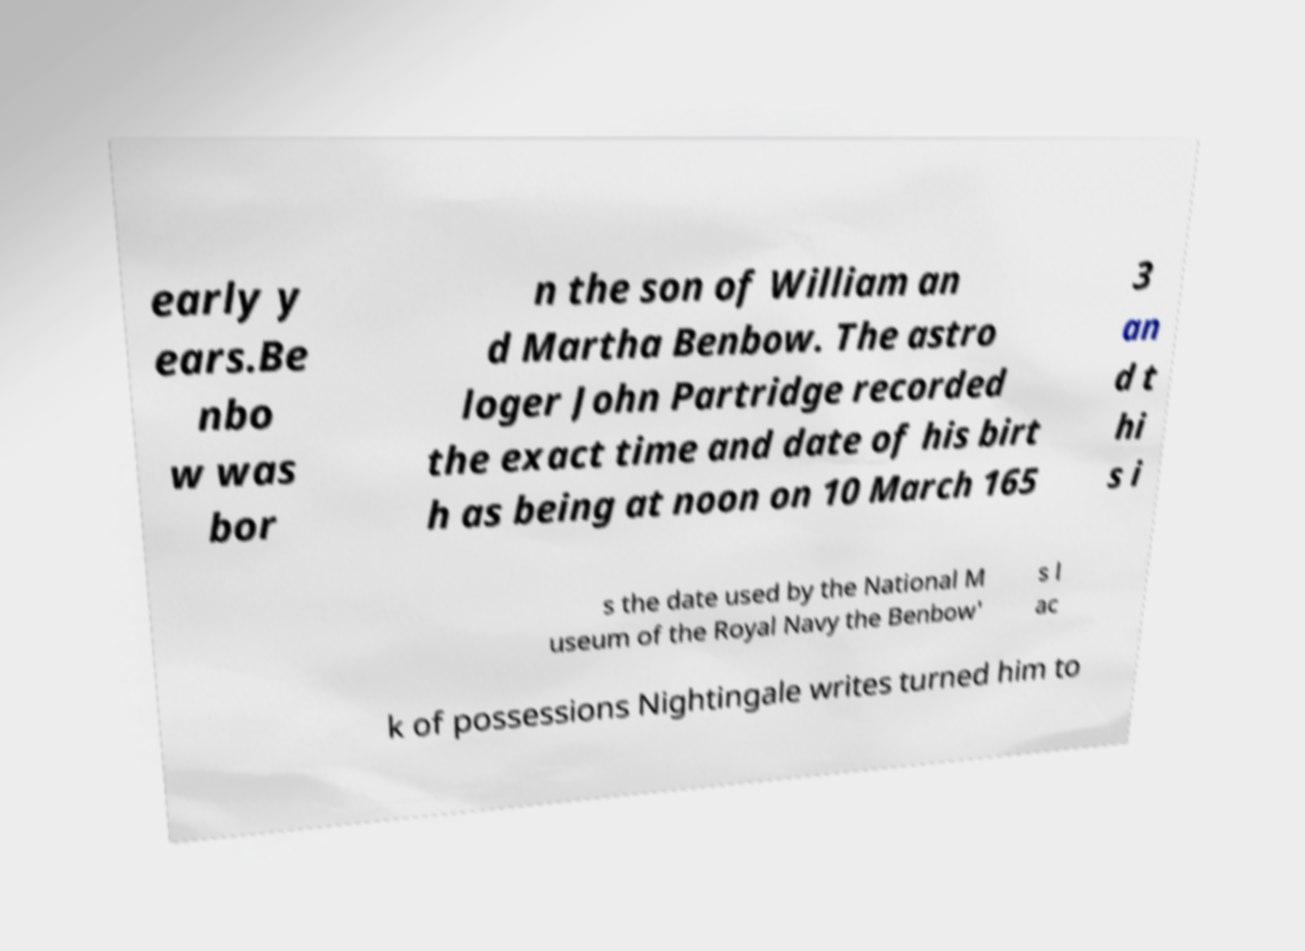What messages or text are displayed in this image? I need them in a readable, typed format. early y ears.Be nbo w was bor n the son of William an d Martha Benbow. The astro loger John Partridge recorded the exact time and date of his birt h as being at noon on 10 March 165 3 an d t hi s i s the date used by the National M useum of the Royal Navy the Benbow' s l ac k of possessions Nightingale writes turned him to 